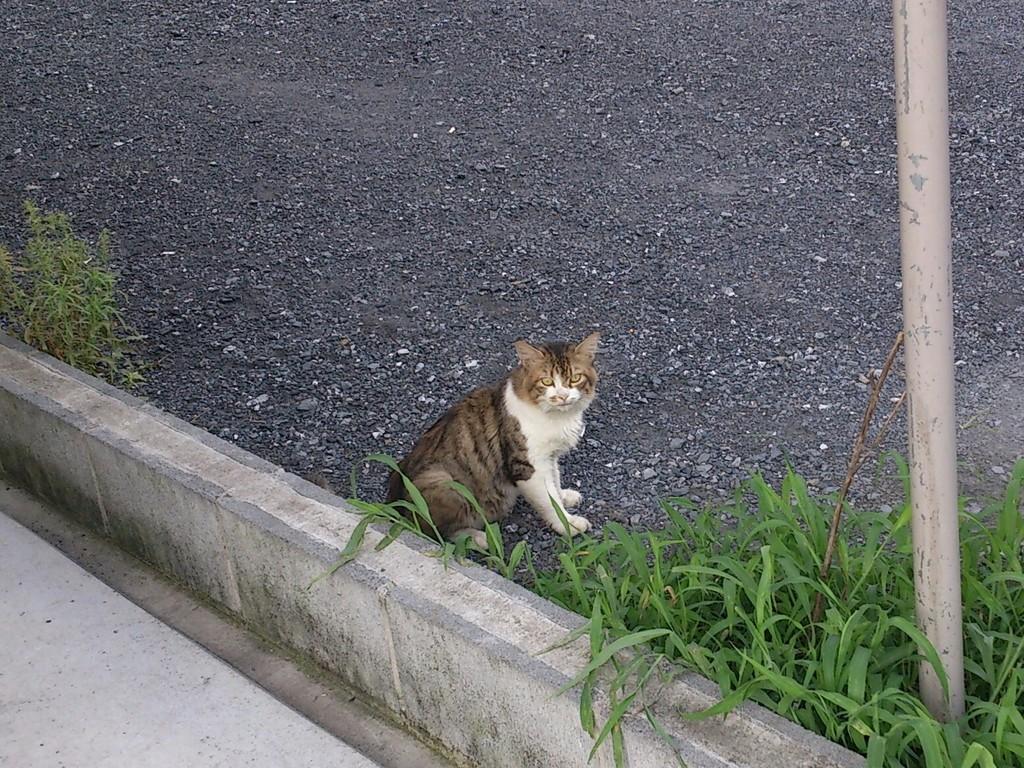How would you summarize this image in a sentence or two? In this picture there is a cat and there is a fence wall behind it and there are small plants and a pole beside it and there are small rocks in the background. 